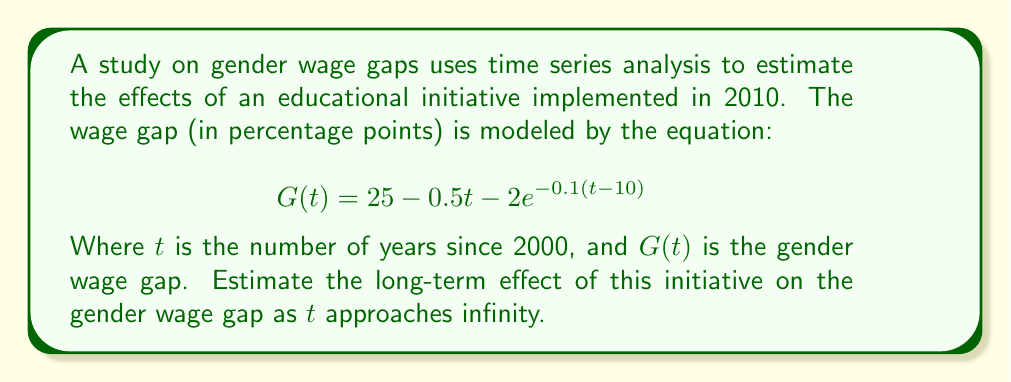Teach me how to tackle this problem. To estimate the long-term effect of the educational initiative on the gender wage gap, we need to analyze the behavior of the function $G(t)$ as $t$ approaches infinity. Let's break this down step-by-step:

1) The given function is:
   $$G(t) = 25 - 0.5t - 2e^{-0.1(t-10)}$$

2) As $t$ approaches infinity, we need to consider the limit:
   $$\lim_{t \to \infty} G(t) = \lim_{t \to \infty} (25 - 0.5t - 2e^{-0.1(t-10)})$$

3) Let's analyze each term:
   a) The constant term 25 remains unchanged.
   b) The term $-0.5t$ approaches negative infinity as $t$ increases.
   c) For the exponential term $-2e^{-0.1(t-10)}$:
      As $t$ increases, $-0.1(t-10)$ becomes a large negative number, so $e^{-0.1(t-10)}$ approaches 0.

4) Therefore, as $t$ approaches infinity:
   $$\lim_{t \to \infty} G(t) = -\infty$$

5) This means that in the very long term, the model predicts the gender wage gap will not only close but will continue to decrease indefinitely, which is not realistic in practice.

6) To find a more meaningful long-term effect, we can consider when the gap closes (i.e., when $G(t) = 0$). However, solving this equation analytically is complex due to the exponential term.

7) In practice, we would use numerical methods to find when $G(t)$ first becomes zero, which would give us an estimate of when the wage gap is predicted to close under this model.

8) The long-term effect of the initiative can be described as contributing to a consistent decrease in the wage gap, eventually leading to its closure and a potential reversal if the trend continues unchecked.
Answer: The model predicts the gender wage gap will close and continue to decrease indefinitely, suggesting a significant long-term impact of the educational initiative. 